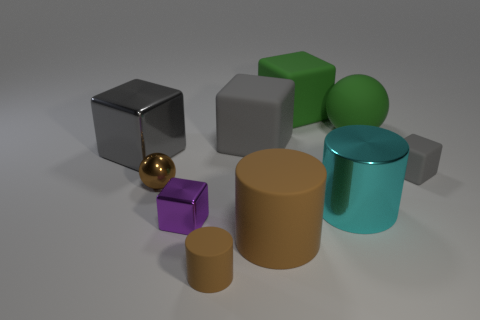What number of matte objects have the same color as the rubber ball?
Offer a very short reply. 1. Are there more large gray blocks on the right side of the small sphere than large gray cubes in front of the small purple shiny thing?
Your answer should be very brief. Yes. Are there any other things that are the same color as the tiny rubber cylinder?
Ensure brevity in your answer.  Yes. There is a rubber cylinder that is left of the big matte object that is in front of the small gray matte block; are there any green matte balls that are behind it?
Ensure brevity in your answer.  Yes. There is a small brown thing that is on the left side of the tiny purple metallic object; is it the same shape as the gray metal object?
Your answer should be compact. No. Is the number of purple metallic objects that are in front of the big rubber cylinder less than the number of green cubes that are in front of the tiny cylinder?
Keep it short and to the point. No. What material is the small brown ball?
Provide a short and direct response. Metal. There is a matte ball; is it the same color as the small metallic cube that is right of the tiny brown shiny ball?
Give a very brief answer. No. How many gray blocks are to the left of the large cyan metallic cylinder?
Keep it short and to the point. 2. Is the number of metal cylinders that are in front of the big brown matte cylinder less than the number of big yellow cylinders?
Offer a terse response. No. 